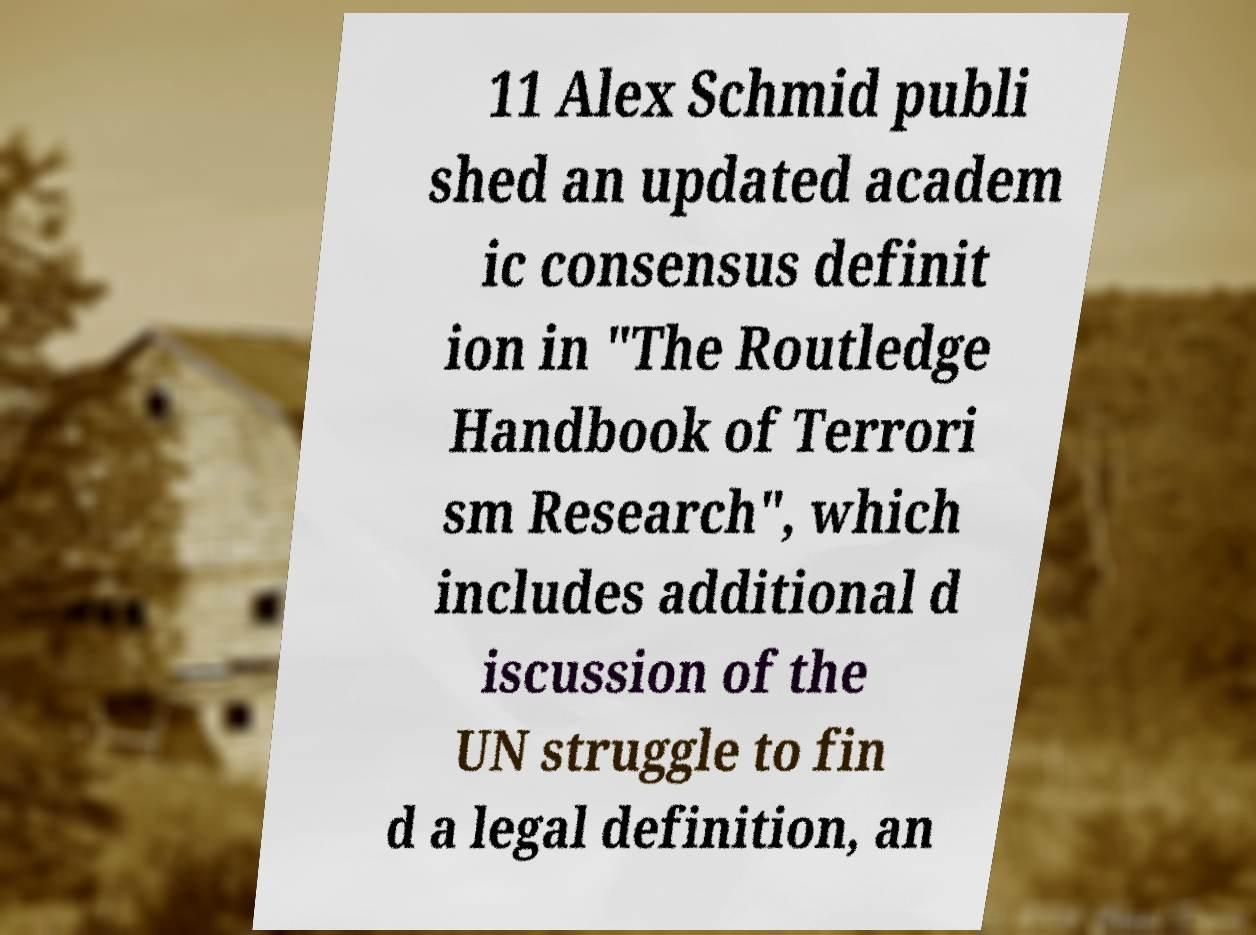What messages or text are displayed in this image? I need them in a readable, typed format. 11 Alex Schmid publi shed an updated academ ic consensus definit ion in "The Routledge Handbook of Terrori sm Research", which includes additional d iscussion of the UN struggle to fin d a legal definition, an 